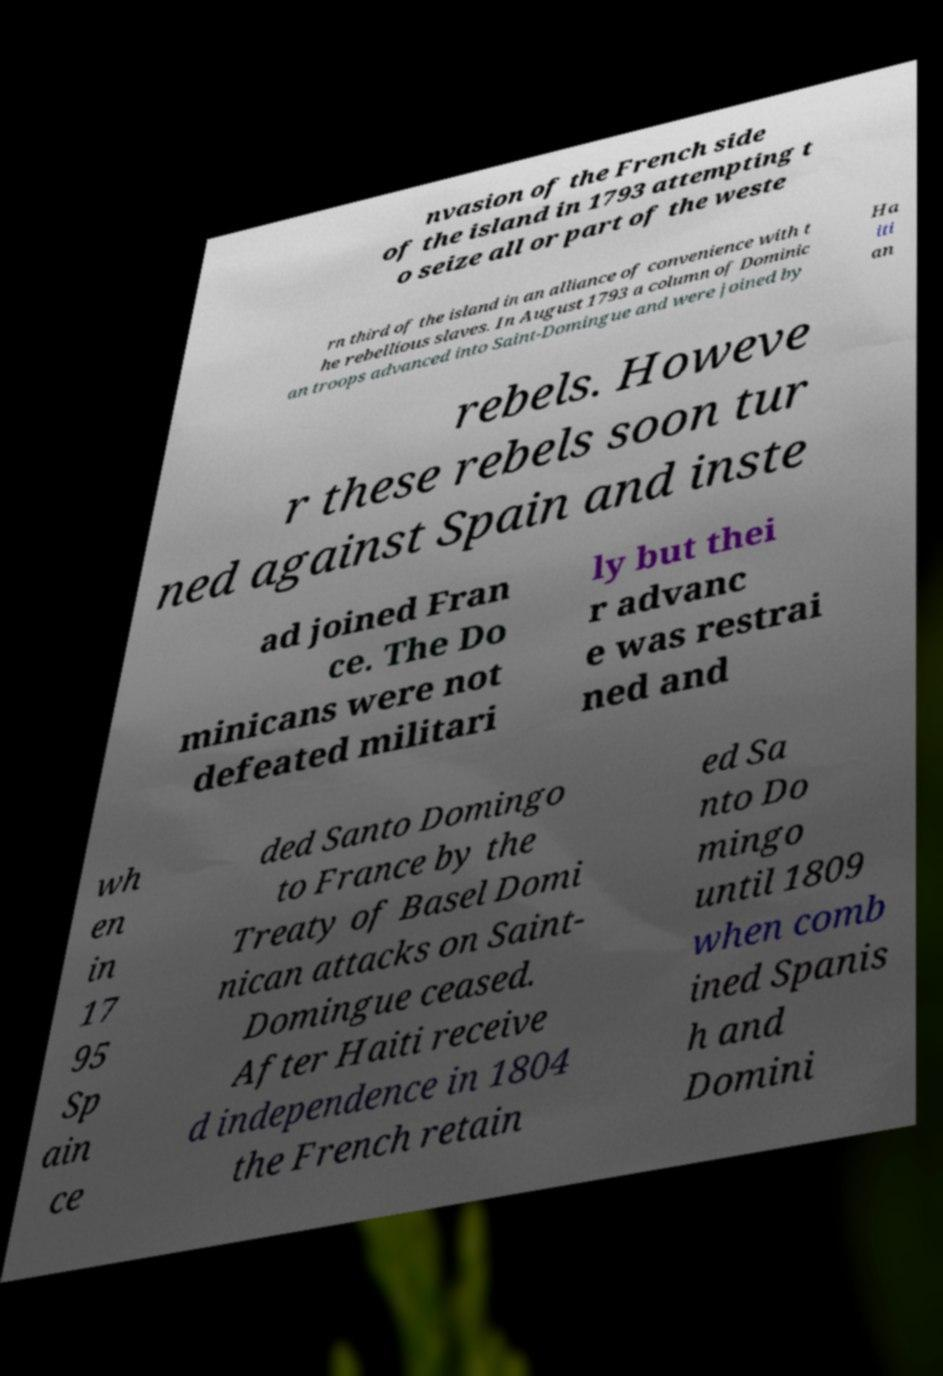For documentation purposes, I need the text within this image transcribed. Could you provide that? nvasion of the French side of the island in 1793 attempting t o seize all or part of the weste rn third of the island in an alliance of convenience with t he rebellious slaves. In August 1793 a column of Dominic an troops advanced into Saint-Domingue and were joined by Ha iti an rebels. Howeve r these rebels soon tur ned against Spain and inste ad joined Fran ce. The Do minicans were not defeated militari ly but thei r advanc e was restrai ned and wh en in 17 95 Sp ain ce ded Santo Domingo to France by the Treaty of Basel Domi nican attacks on Saint- Domingue ceased. After Haiti receive d independence in 1804 the French retain ed Sa nto Do mingo until 1809 when comb ined Spanis h and Domini 